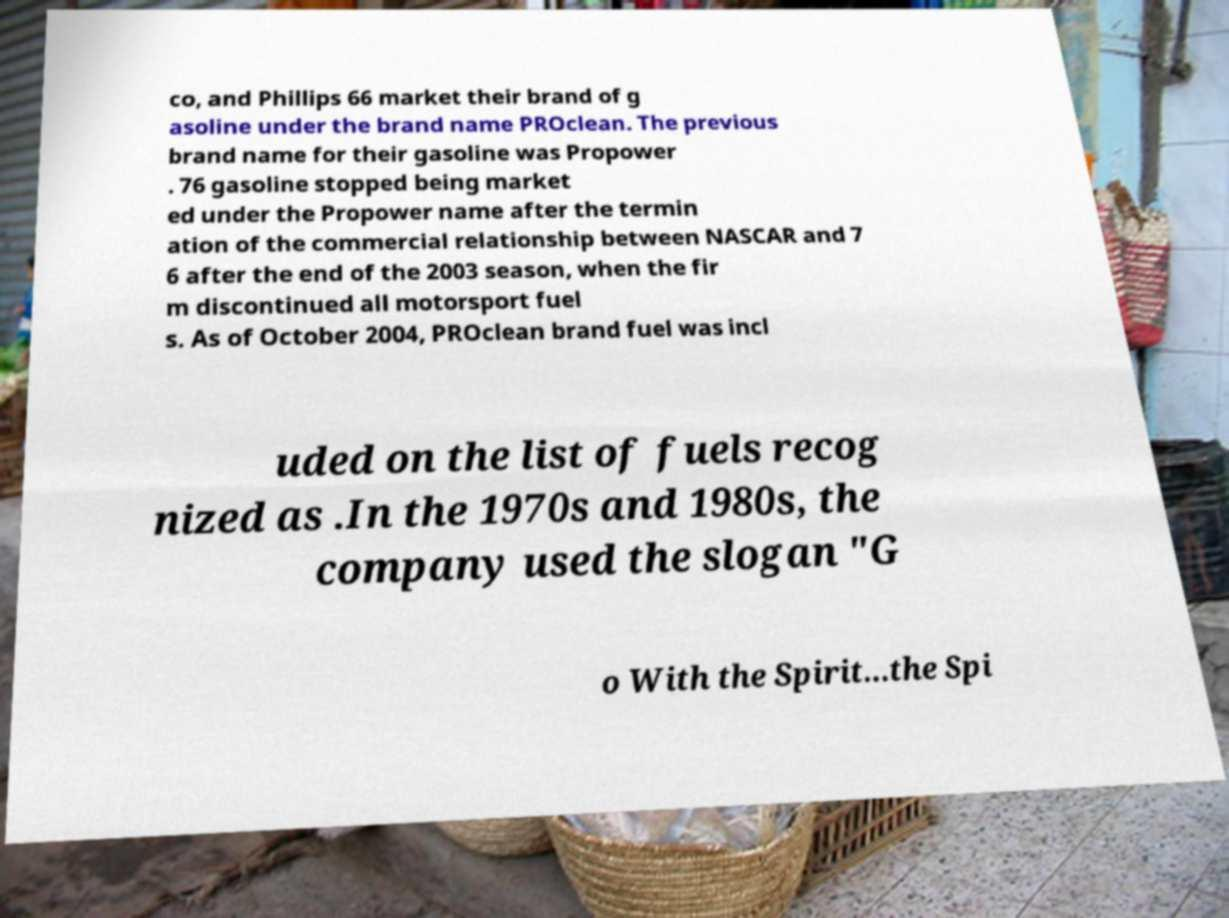Please identify and transcribe the text found in this image. co, and Phillips 66 market their brand of g asoline under the brand name PROclean. The previous brand name for their gasoline was Propower . 76 gasoline stopped being market ed under the Propower name after the termin ation of the commercial relationship between NASCAR and 7 6 after the end of the 2003 season, when the fir m discontinued all motorsport fuel s. As of October 2004, PROclean brand fuel was incl uded on the list of fuels recog nized as .In the 1970s and 1980s, the company used the slogan "G o With the Spirit...the Spi 